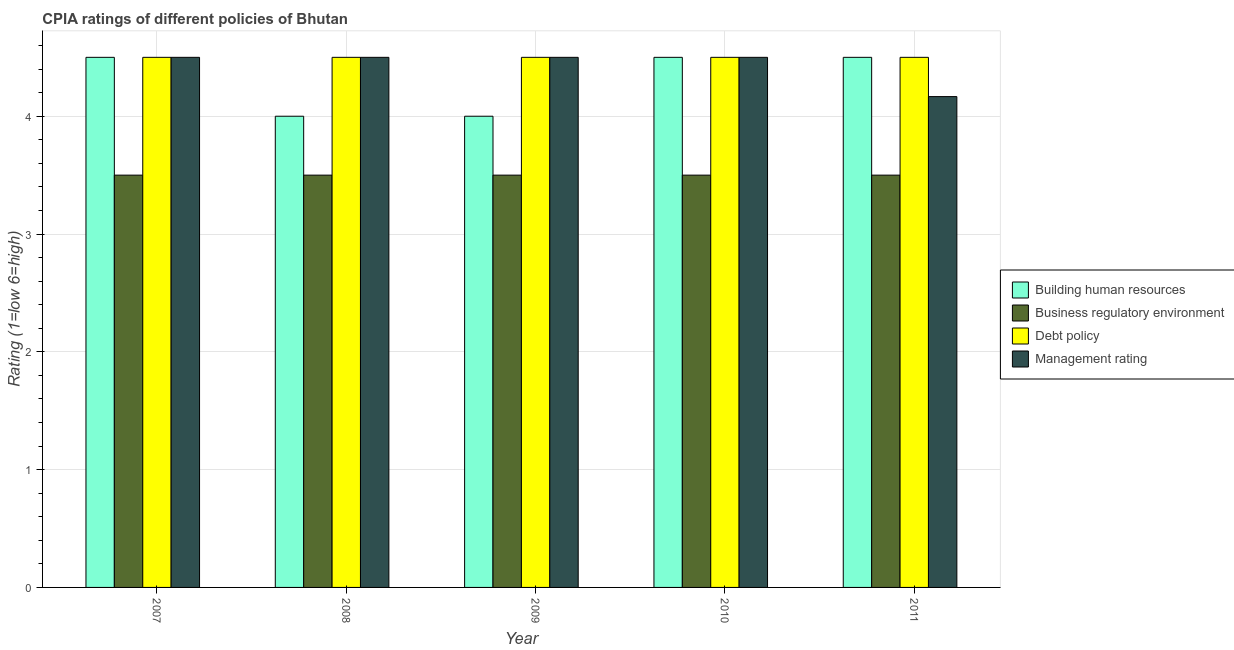How many groups of bars are there?
Your answer should be very brief. 5. How many bars are there on the 2nd tick from the left?
Ensure brevity in your answer.  4. How many bars are there on the 3rd tick from the right?
Provide a short and direct response. 4. What is the label of the 5th group of bars from the left?
Ensure brevity in your answer.  2011. Across all years, what is the maximum cpia rating of business regulatory environment?
Make the answer very short. 3.5. In which year was the cpia rating of management maximum?
Your answer should be compact. 2007. What is the difference between the cpia rating of debt policy in 2008 and that in 2010?
Offer a terse response. 0. What is the average cpia rating of building human resources per year?
Make the answer very short. 4.3. What is the ratio of the cpia rating of building human resources in 2007 to that in 2010?
Provide a succinct answer. 1. Is the cpia rating of debt policy in 2008 less than that in 2010?
Your answer should be compact. No. What is the difference between the highest and the second highest cpia rating of management?
Your answer should be compact. 0. In how many years, is the cpia rating of business regulatory environment greater than the average cpia rating of business regulatory environment taken over all years?
Provide a short and direct response. 0. Is the sum of the cpia rating of business regulatory environment in 2010 and 2011 greater than the maximum cpia rating of debt policy across all years?
Offer a terse response. Yes. Is it the case that in every year, the sum of the cpia rating of debt policy and cpia rating of business regulatory environment is greater than the sum of cpia rating of management and cpia rating of building human resources?
Your answer should be compact. No. What does the 1st bar from the left in 2008 represents?
Ensure brevity in your answer.  Building human resources. What does the 3rd bar from the right in 2007 represents?
Your answer should be very brief. Business regulatory environment. How many bars are there?
Your response must be concise. 20. Are all the bars in the graph horizontal?
Give a very brief answer. No. How many years are there in the graph?
Offer a terse response. 5. What is the difference between two consecutive major ticks on the Y-axis?
Keep it short and to the point. 1. Are the values on the major ticks of Y-axis written in scientific E-notation?
Give a very brief answer. No. Does the graph contain any zero values?
Make the answer very short. No. Where does the legend appear in the graph?
Your answer should be compact. Center right. How many legend labels are there?
Your answer should be very brief. 4. What is the title of the graph?
Keep it short and to the point. CPIA ratings of different policies of Bhutan. What is the label or title of the Y-axis?
Make the answer very short. Rating (1=low 6=high). What is the Rating (1=low 6=high) of Management rating in 2007?
Make the answer very short. 4.5. What is the Rating (1=low 6=high) in Building human resources in 2008?
Your response must be concise. 4. What is the Rating (1=low 6=high) of Debt policy in 2008?
Ensure brevity in your answer.  4.5. What is the Rating (1=low 6=high) in Building human resources in 2009?
Provide a short and direct response. 4. What is the Rating (1=low 6=high) in Debt policy in 2009?
Give a very brief answer. 4.5. What is the Rating (1=low 6=high) of Building human resources in 2010?
Make the answer very short. 4.5. What is the Rating (1=low 6=high) in Debt policy in 2010?
Your response must be concise. 4.5. What is the Rating (1=low 6=high) of Building human resources in 2011?
Provide a succinct answer. 4.5. What is the Rating (1=low 6=high) of Management rating in 2011?
Keep it short and to the point. 4.17. Across all years, what is the maximum Rating (1=low 6=high) in Building human resources?
Give a very brief answer. 4.5. Across all years, what is the maximum Rating (1=low 6=high) of Management rating?
Offer a terse response. 4.5. Across all years, what is the minimum Rating (1=low 6=high) in Debt policy?
Provide a succinct answer. 4.5. Across all years, what is the minimum Rating (1=low 6=high) of Management rating?
Offer a very short reply. 4.17. What is the total Rating (1=low 6=high) of Building human resources in the graph?
Give a very brief answer. 21.5. What is the total Rating (1=low 6=high) of Debt policy in the graph?
Your answer should be compact. 22.5. What is the total Rating (1=low 6=high) of Management rating in the graph?
Make the answer very short. 22.17. What is the difference between the Rating (1=low 6=high) of Building human resources in 2007 and that in 2008?
Provide a succinct answer. 0.5. What is the difference between the Rating (1=low 6=high) in Business regulatory environment in 2007 and that in 2008?
Offer a terse response. 0. What is the difference between the Rating (1=low 6=high) of Building human resources in 2007 and that in 2009?
Make the answer very short. 0.5. What is the difference between the Rating (1=low 6=high) in Debt policy in 2007 and that in 2009?
Give a very brief answer. 0. What is the difference between the Rating (1=low 6=high) in Management rating in 2007 and that in 2010?
Ensure brevity in your answer.  0. What is the difference between the Rating (1=low 6=high) in Building human resources in 2007 and that in 2011?
Provide a short and direct response. 0. What is the difference between the Rating (1=low 6=high) of Business regulatory environment in 2007 and that in 2011?
Provide a succinct answer. 0. What is the difference between the Rating (1=low 6=high) of Building human resources in 2008 and that in 2009?
Your answer should be compact. 0. What is the difference between the Rating (1=low 6=high) of Business regulatory environment in 2008 and that in 2009?
Offer a very short reply. 0. What is the difference between the Rating (1=low 6=high) of Building human resources in 2008 and that in 2010?
Your answer should be compact. -0.5. What is the difference between the Rating (1=low 6=high) in Management rating in 2008 and that in 2010?
Your answer should be very brief. 0. What is the difference between the Rating (1=low 6=high) of Debt policy in 2008 and that in 2011?
Your answer should be very brief. 0. What is the difference between the Rating (1=low 6=high) of Building human resources in 2009 and that in 2010?
Offer a very short reply. -0.5. What is the difference between the Rating (1=low 6=high) in Debt policy in 2009 and that in 2010?
Give a very brief answer. 0. What is the difference between the Rating (1=low 6=high) of Management rating in 2009 and that in 2010?
Provide a succinct answer. 0. What is the difference between the Rating (1=low 6=high) of Building human resources in 2009 and that in 2011?
Keep it short and to the point. -0.5. What is the difference between the Rating (1=low 6=high) of Business regulatory environment in 2009 and that in 2011?
Your answer should be very brief. 0. What is the difference between the Rating (1=low 6=high) of Management rating in 2009 and that in 2011?
Offer a very short reply. 0.33. What is the difference between the Rating (1=low 6=high) of Building human resources in 2007 and the Rating (1=low 6=high) of Business regulatory environment in 2008?
Make the answer very short. 1. What is the difference between the Rating (1=low 6=high) of Building human resources in 2007 and the Rating (1=low 6=high) of Debt policy in 2008?
Offer a terse response. 0. What is the difference between the Rating (1=low 6=high) of Building human resources in 2007 and the Rating (1=low 6=high) of Management rating in 2008?
Provide a succinct answer. 0. What is the difference between the Rating (1=low 6=high) in Building human resources in 2007 and the Rating (1=low 6=high) in Business regulatory environment in 2009?
Your response must be concise. 1. What is the difference between the Rating (1=low 6=high) in Building human resources in 2007 and the Rating (1=low 6=high) in Debt policy in 2009?
Your response must be concise. 0. What is the difference between the Rating (1=low 6=high) in Building human resources in 2007 and the Rating (1=low 6=high) in Management rating in 2009?
Offer a very short reply. 0. What is the difference between the Rating (1=low 6=high) of Business regulatory environment in 2007 and the Rating (1=low 6=high) of Debt policy in 2009?
Offer a terse response. -1. What is the difference between the Rating (1=low 6=high) of Debt policy in 2007 and the Rating (1=low 6=high) of Management rating in 2009?
Your answer should be very brief. 0. What is the difference between the Rating (1=low 6=high) of Building human resources in 2007 and the Rating (1=low 6=high) of Management rating in 2010?
Make the answer very short. 0. What is the difference between the Rating (1=low 6=high) of Debt policy in 2007 and the Rating (1=low 6=high) of Management rating in 2010?
Offer a terse response. 0. What is the difference between the Rating (1=low 6=high) in Building human resources in 2007 and the Rating (1=low 6=high) in Management rating in 2011?
Offer a terse response. 0.33. What is the difference between the Rating (1=low 6=high) of Building human resources in 2008 and the Rating (1=low 6=high) of Business regulatory environment in 2009?
Your answer should be very brief. 0.5. What is the difference between the Rating (1=low 6=high) in Building human resources in 2008 and the Rating (1=low 6=high) in Debt policy in 2009?
Provide a short and direct response. -0.5. What is the difference between the Rating (1=low 6=high) of Building human resources in 2008 and the Rating (1=low 6=high) of Management rating in 2009?
Your answer should be compact. -0.5. What is the difference between the Rating (1=low 6=high) of Business regulatory environment in 2008 and the Rating (1=low 6=high) of Debt policy in 2009?
Keep it short and to the point. -1. What is the difference between the Rating (1=low 6=high) in Building human resources in 2008 and the Rating (1=low 6=high) in Debt policy in 2010?
Your response must be concise. -0.5. What is the difference between the Rating (1=low 6=high) in Business regulatory environment in 2008 and the Rating (1=low 6=high) in Management rating in 2010?
Your answer should be very brief. -1. What is the difference between the Rating (1=low 6=high) of Building human resources in 2008 and the Rating (1=low 6=high) of Business regulatory environment in 2011?
Offer a very short reply. 0.5. What is the difference between the Rating (1=low 6=high) of Building human resources in 2008 and the Rating (1=low 6=high) of Debt policy in 2011?
Your response must be concise. -0.5. What is the difference between the Rating (1=low 6=high) in Building human resources in 2009 and the Rating (1=low 6=high) in Business regulatory environment in 2010?
Offer a very short reply. 0.5. What is the difference between the Rating (1=low 6=high) of Building human resources in 2009 and the Rating (1=low 6=high) of Debt policy in 2010?
Your answer should be compact. -0.5. What is the difference between the Rating (1=low 6=high) of Building human resources in 2009 and the Rating (1=low 6=high) of Management rating in 2010?
Give a very brief answer. -0.5. What is the difference between the Rating (1=low 6=high) of Business regulatory environment in 2009 and the Rating (1=low 6=high) of Management rating in 2010?
Make the answer very short. -1. What is the difference between the Rating (1=low 6=high) of Building human resources in 2009 and the Rating (1=low 6=high) of Debt policy in 2011?
Offer a terse response. -0.5. What is the difference between the Rating (1=low 6=high) of Business regulatory environment in 2009 and the Rating (1=low 6=high) of Debt policy in 2011?
Your answer should be compact. -1. What is the difference between the Rating (1=low 6=high) of Debt policy in 2009 and the Rating (1=low 6=high) of Management rating in 2011?
Ensure brevity in your answer.  0.33. What is the difference between the Rating (1=low 6=high) of Building human resources in 2010 and the Rating (1=low 6=high) of Business regulatory environment in 2011?
Give a very brief answer. 1. What is the difference between the Rating (1=low 6=high) of Building human resources in 2010 and the Rating (1=low 6=high) of Debt policy in 2011?
Make the answer very short. 0. What is the difference between the Rating (1=low 6=high) of Building human resources in 2010 and the Rating (1=low 6=high) of Management rating in 2011?
Keep it short and to the point. 0.33. What is the difference between the Rating (1=low 6=high) in Business regulatory environment in 2010 and the Rating (1=low 6=high) in Debt policy in 2011?
Your answer should be very brief. -1. What is the difference between the Rating (1=low 6=high) of Debt policy in 2010 and the Rating (1=low 6=high) of Management rating in 2011?
Offer a terse response. 0.33. What is the average Rating (1=low 6=high) in Business regulatory environment per year?
Your answer should be compact. 3.5. What is the average Rating (1=low 6=high) of Debt policy per year?
Keep it short and to the point. 4.5. What is the average Rating (1=low 6=high) of Management rating per year?
Keep it short and to the point. 4.43. In the year 2007, what is the difference between the Rating (1=low 6=high) of Building human resources and Rating (1=low 6=high) of Business regulatory environment?
Give a very brief answer. 1. In the year 2007, what is the difference between the Rating (1=low 6=high) of Building human resources and Rating (1=low 6=high) of Debt policy?
Make the answer very short. 0. In the year 2007, what is the difference between the Rating (1=low 6=high) of Building human resources and Rating (1=low 6=high) of Management rating?
Offer a terse response. 0. In the year 2008, what is the difference between the Rating (1=low 6=high) of Building human resources and Rating (1=low 6=high) of Management rating?
Your answer should be compact. -0.5. In the year 2008, what is the difference between the Rating (1=low 6=high) in Business regulatory environment and Rating (1=low 6=high) in Management rating?
Offer a very short reply. -1. In the year 2009, what is the difference between the Rating (1=low 6=high) of Building human resources and Rating (1=low 6=high) of Debt policy?
Ensure brevity in your answer.  -0.5. In the year 2009, what is the difference between the Rating (1=low 6=high) of Debt policy and Rating (1=low 6=high) of Management rating?
Offer a very short reply. 0. In the year 2010, what is the difference between the Rating (1=low 6=high) in Building human resources and Rating (1=low 6=high) in Business regulatory environment?
Make the answer very short. 1. In the year 2010, what is the difference between the Rating (1=low 6=high) of Building human resources and Rating (1=low 6=high) of Management rating?
Make the answer very short. 0. In the year 2010, what is the difference between the Rating (1=low 6=high) in Debt policy and Rating (1=low 6=high) in Management rating?
Your answer should be compact. 0. In the year 2011, what is the difference between the Rating (1=low 6=high) of Building human resources and Rating (1=low 6=high) of Business regulatory environment?
Provide a succinct answer. 1. In the year 2011, what is the difference between the Rating (1=low 6=high) in Building human resources and Rating (1=low 6=high) in Debt policy?
Your response must be concise. 0. In the year 2011, what is the difference between the Rating (1=low 6=high) of Business regulatory environment and Rating (1=low 6=high) of Debt policy?
Your answer should be very brief. -1. In the year 2011, what is the difference between the Rating (1=low 6=high) in Business regulatory environment and Rating (1=low 6=high) in Management rating?
Give a very brief answer. -0.67. In the year 2011, what is the difference between the Rating (1=low 6=high) of Debt policy and Rating (1=low 6=high) of Management rating?
Make the answer very short. 0.33. What is the ratio of the Rating (1=low 6=high) in Building human resources in 2007 to that in 2008?
Provide a short and direct response. 1.12. What is the ratio of the Rating (1=low 6=high) in Business regulatory environment in 2007 to that in 2010?
Your response must be concise. 1. What is the ratio of the Rating (1=low 6=high) of Debt policy in 2007 to that in 2010?
Offer a terse response. 1. What is the ratio of the Rating (1=low 6=high) in Building human resources in 2007 to that in 2011?
Ensure brevity in your answer.  1. What is the ratio of the Rating (1=low 6=high) of Business regulatory environment in 2007 to that in 2011?
Provide a succinct answer. 1. What is the ratio of the Rating (1=low 6=high) of Debt policy in 2007 to that in 2011?
Offer a very short reply. 1. What is the ratio of the Rating (1=low 6=high) in Management rating in 2007 to that in 2011?
Give a very brief answer. 1.08. What is the ratio of the Rating (1=low 6=high) of Building human resources in 2008 to that in 2009?
Offer a very short reply. 1. What is the ratio of the Rating (1=low 6=high) of Debt policy in 2008 to that in 2009?
Offer a terse response. 1. What is the ratio of the Rating (1=low 6=high) of Building human resources in 2008 to that in 2010?
Ensure brevity in your answer.  0.89. What is the ratio of the Rating (1=low 6=high) of Debt policy in 2008 to that in 2010?
Your answer should be very brief. 1. What is the ratio of the Rating (1=low 6=high) of Management rating in 2008 to that in 2010?
Your answer should be compact. 1. What is the ratio of the Rating (1=low 6=high) in Building human resources in 2008 to that in 2011?
Your answer should be very brief. 0.89. What is the ratio of the Rating (1=low 6=high) in Management rating in 2008 to that in 2011?
Your answer should be compact. 1.08. What is the ratio of the Rating (1=low 6=high) in Debt policy in 2009 to that in 2010?
Offer a very short reply. 1. What is the ratio of the Rating (1=low 6=high) in Management rating in 2009 to that in 2010?
Keep it short and to the point. 1. What is the ratio of the Rating (1=low 6=high) in Building human resources in 2010 to that in 2011?
Give a very brief answer. 1. What is the difference between the highest and the second highest Rating (1=low 6=high) in Management rating?
Ensure brevity in your answer.  0. What is the difference between the highest and the lowest Rating (1=low 6=high) of Building human resources?
Give a very brief answer. 0.5. What is the difference between the highest and the lowest Rating (1=low 6=high) in Debt policy?
Make the answer very short. 0. What is the difference between the highest and the lowest Rating (1=low 6=high) in Management rating?
Make the answer very short. 0.33. 